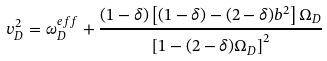<formula> <loc_0><loc_0><loc_500><loc_500>v _ { D } ^ { 2 } = \omega ^ { e f f } _ { D } + \frac { ( 1 - \delta ) \left [ ( 1 - \delta ) - ( 2 - \delta ) b ^ { 2 } \right ] \Omega _ { D } } { \left [ 1 - ( 2 - \delta ) \Omega _ { D } \right ] ^ { 2 } }</formula> 